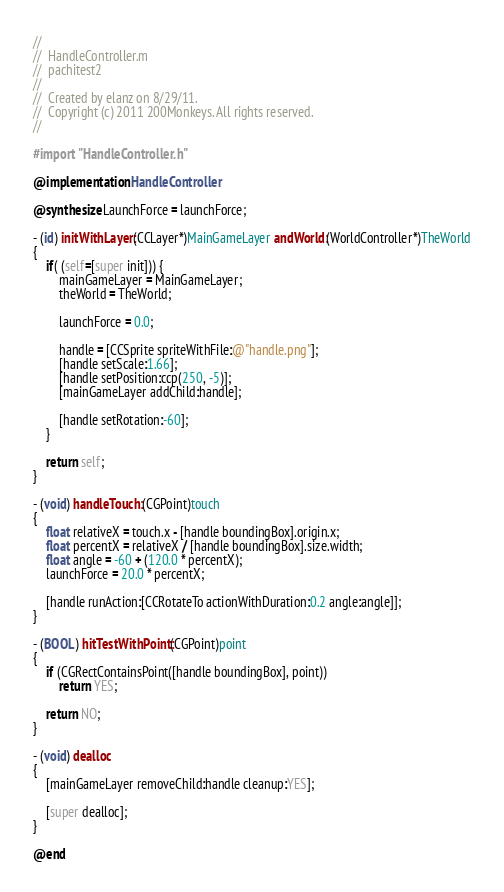Convert code to text. <code><loc_0><loc_0><loc_500><loc_500><_ObjectiveC_>//
//  HandleController.m
//  pachitest2
//
//  Created by elanz on 8/29/11.
//  Copyright (c) 2011 200Monkeys. All rights reserved.
//

#import "HandleController.h"

@implementation HandleController

@synthesize LaunchForce = launchForce;

- (id) initWithLayer:(CCLayer*)MainGameLayer andWorld:(WorldController*)TheWorld
{
    if( (self=[super init])) {
        mainGameLayer = MainGameLayer;
        theWorld = TheWorld;
        
        launchForce = 0.0;
        
        handle = [CCSprite spriteWithFile:@"handle.png"];
        [handle setScale:1.66];
        [handle setPosition:ccp(250, -5)];
        [mainGameLayer addChild:handle];

        [handle setRotation:-60];
    }
    
    return self;
}

- (void) handleTouch:(CGPoint)touch
{
    float relativeX = touch.x - [handle boundingBox].origin.x;
    float percentX = relativeX / [handle boundingBox].size.width;
    float angle = -60 + (120.0 * percentX);
    launchForce = 20.0 * percentX;
    
    [handle runAction:[CCRotateTo actionWithDuration:0.2 angle:angle]];
}

- (BOOL) hitTestWithPoint:(CGPoint)point
{ 
    if (CGRectContainsPoint([handle boundingBox], point))
        return YES;
    
    return NO;
}

- (void) dealloc
{
    [mainGameLayer removeChild:handle cleanup:YES];
    
    [super dealloc];
}

@end
</code> 